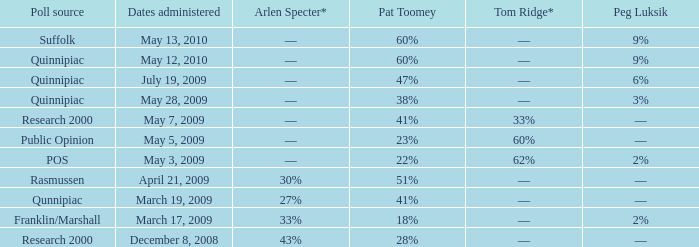Give me the full table as a dictionary. {'header': ['Poll source', 'Dates administered', 'Arlen Specter*', 'Pat Toomey', 'Tom Ridge*', 'Peg Luksik'], 'rows': [['Suffolk', 'May 13, 2010', '––', '60%', '––', '9%'], ['Quinnipiac', 'May 12, 2010', '––', '60%', '––', '9%'], ['Quinnipiac', 'July 19, 2009', '––', '47%', '––', '6%'], ['Quinnipiac', 'May 28, 2009', '––', '38%', '––', '3%'], ['Research 2000', 'May 7, 2009', '––', '41%', '33%', '––'], ['Public Opinion', 'May 5, 2009', '––', '23%', '60%', '––'], ['POS', 'May 3, 2009', '––', '22%', '62%', '2%'], ['Rasmussen', 'April 21, 2009', '30%', '51%', '––', '––'], ['Qunnipiac', 'March 19, 2009', '27%', '41%', '––', '––'], ['Franklin/Marshall', 'March 17, 2009', '33%', '18%', '––', '2%'], ['Research 2000', 'December 8, 2008', '43%', '28%', '––', '––']]} Which Tom Ridge* has a Poll source of research 2000, and an Arlen Specter* of 43%? ––. 